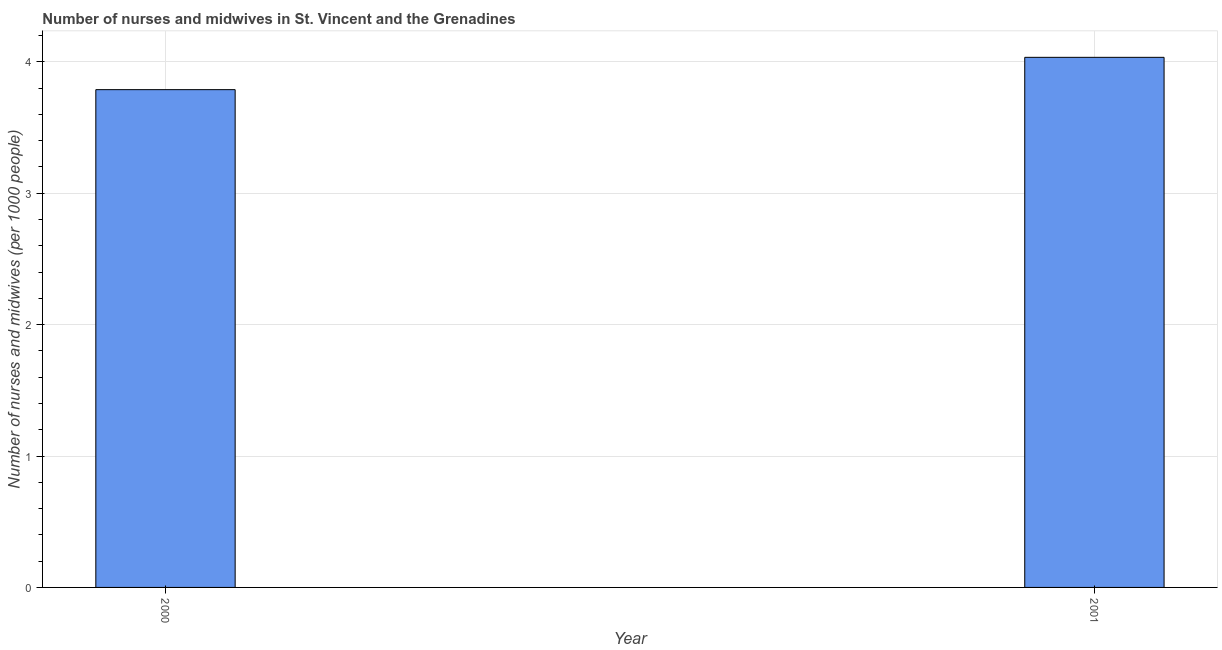Does the graph contain any zero values?
Your answer should be very brief. No. What is the title of the graph?
Your answer should be compact. Number of nurses and midwives in St. Vincent and the Grenadines. What is the label or title of the Y-axis?
Offer a very short reply. Number of nurses and midwives (per 1000 people). What is the number of nurses and midwives in 2000?
Your response must be concise. 3.79. Across all years, what is the maximum number of nurses and midwives?
Give a very brief answer. 4.03. Across all years, what is the minimum number of nurses and midwives?
Ensure brevity in your answer.  3.79. In which year was the number of nurses and midwives maximum?
Your answer should be compact. 2001. What is the sum of the number of nurses and midwives?
Provide a succinct answer. 7.82. What is the difference between the number of nurses and midwives in 2000 and 2001?
Your answer should be very brief. -0.25. What is the average number of nurses and midwives per year?
Make the answer very short. 3.91. What is the median number of nurses and midwives?
Keep it short and to the point. 3.91. What is the ratio of the number of nurses and midwives in 2000 to that in 2001?
Give a very brief answer. 0.94. In how many years, is the number of nurses and midwives greater than the average number of nurses and midwives taken over all years?
Provide a succinct answer. 1. How many bars are there?
Offer a terse response. 2. What is the difference between two consecutive major ticks on the Y-axis?
Your response must be concise. 1. What is the Number of nurses and midwives (per 1000 people) of 2000?
Your answer should be compact. 3.79. What is the Number of nurses and midwives (per 1000 people) in 2001?
Give a very brief answer. 4.03. What is the difference between the Number of nurses and midwives (per 1000 people) in 2000 and 2001?
Offer a very short reply. -0.25. What is the ratio of the Number of nurses and midwives (per 1000 people) in 2000 to that in 2001?
Offer a terse response. 0.94. 